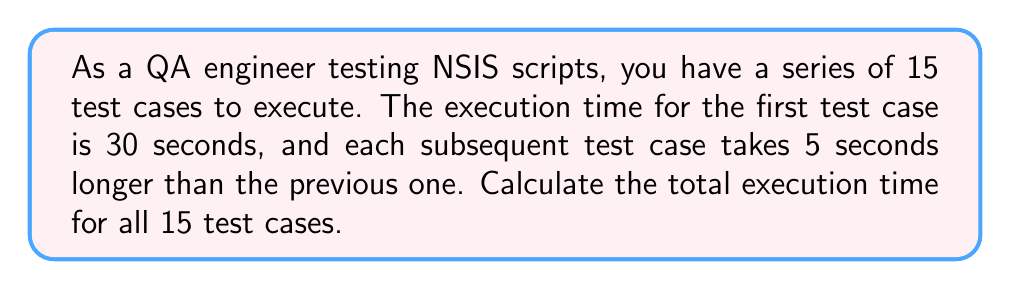What is the answer to this math problem? To solve this problem, we need to use the formula for the sum of an arithmetic sequence:

$$S_n = \frac{n}{2}(a_1 + a_n)$$

Where:
$S_n$ is the sum of the sequence
$n$ is the number of terms
$a_1$ is the first term
$a_n$ is the last term

Steps:
1. Identify the given information:
   $n = 15$ (number of test cases)
   $a_1 = 30$ seconds (first test case execution time)
   $d = 5$ seconds (common difference between consecutive test cases)

2. Calculate the last term ($a_n$):
   $a_n = a_1 + (n-1)d$
   $a_{15} = 30 + (15-1)5 = 30 + 70 = 100$ seconds

3. Apply the formula:
   $$S_{15} = \frac{15}{2}(30 + 100)$$
   $$S_{15} = \frac{15}{2}(130)$$
   $$S_{15} = 15 \times 65 = 975$$ seconds

Therefore, the total execution time for all 15 test cases is 975 seconds.
Answer: 975 seconds 